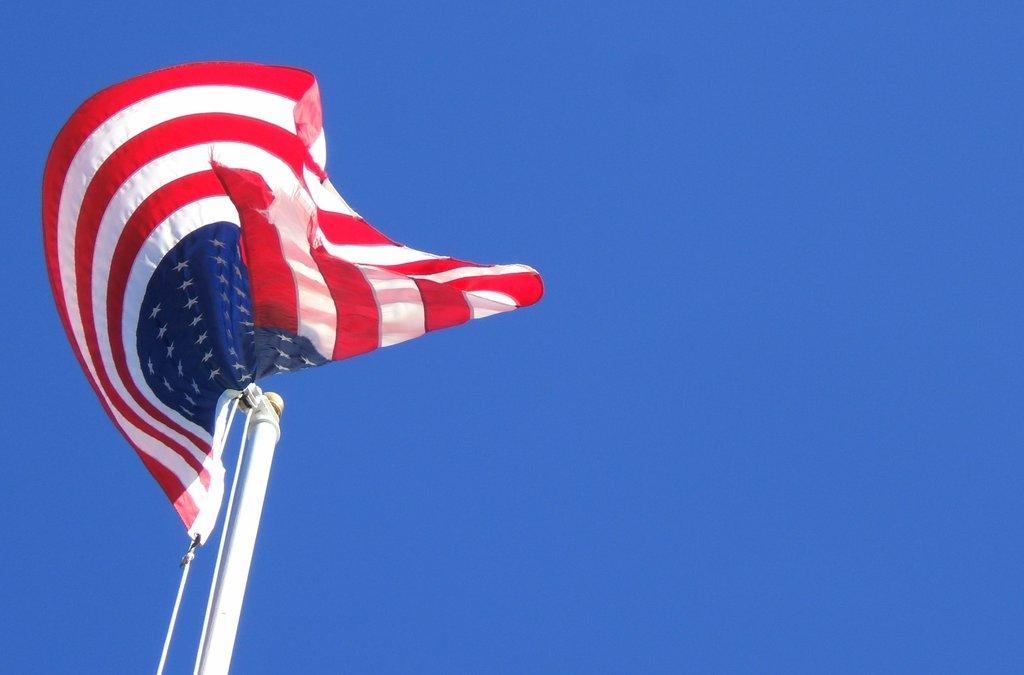What object is present in the image that represents a country or organization? There is a flag in the image. How is the flag positioned in the image? The flag is hanging from a pole. What is attached to the pole in the image? There is a rope hanging from the pole. What can be seen in the background of the image? The sky is visible in the background of the image. What type of thrill can be experienced by the flag in the image? The flag in the image is not experiencing any thrill, as it is stationary and not engaged in any activity. 